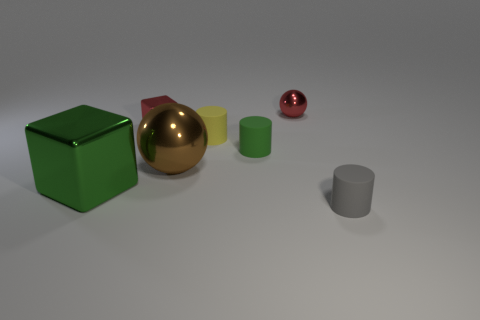Add 1 red metallic balls. How many objects exist? 8 Subtract all green blocks. How many blocks are left? 1 Subtract all yellow rubber cylinders. How many cylinders are left? 2 Subtract all balls. How many objects are left? 5 Subtract 3 cylinders. How many cylinders are left? 0 Subtract all cyan blocks. How many blue spheres are left? 0 Subtract all small gray metallic spheres. Subtract all shiny objects. How many objects are left? 3 Add 1 gray rubber cylinders. How many gray rubber cylinders are left? 2 Add 1 tiny red shiny spheres. How many tiny red shiny spheres exist? 2 Subtract 0 cyan cubes. How many objects are left? 7 